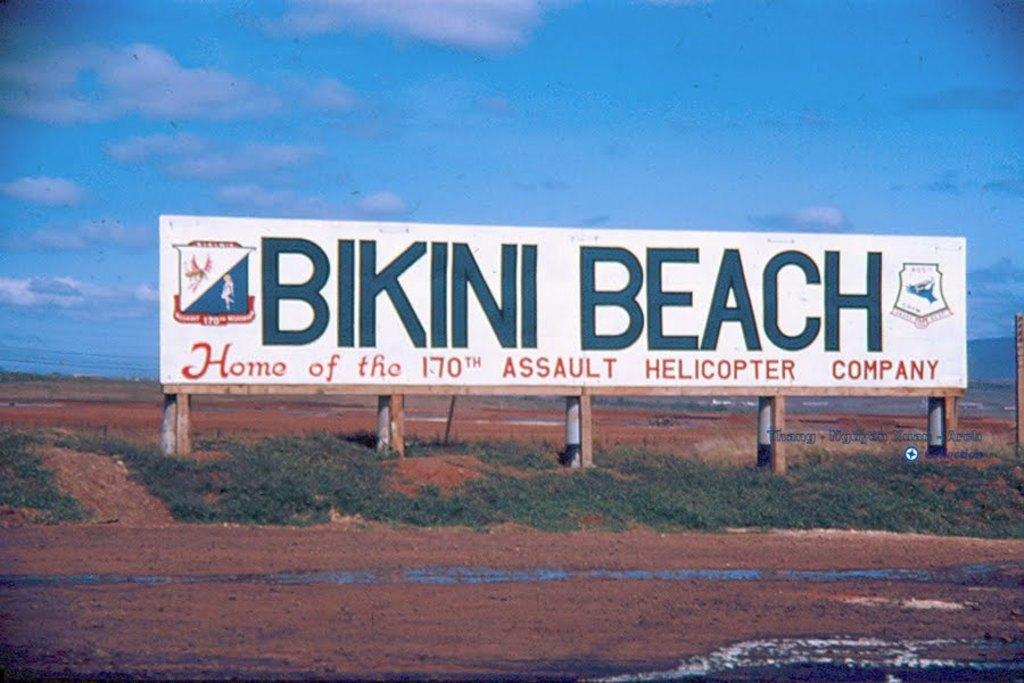<image>
Write a terse but informative summary of the picture. A sign says that Bikini Beach is home to a military helicopter company. 